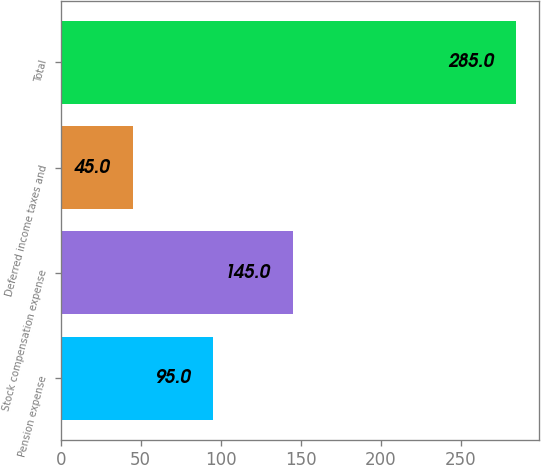Convert chart. <chart><loc_0><loc_0><loc_500><loc_500><bar_chart><fcel>Pension expense<fcel>Stock compensation expense<fcel>Deferred income taxes and<fcel>Total<nl><fcel>95<fcel>145<fcel>45<fcel>285<nl></chart> 